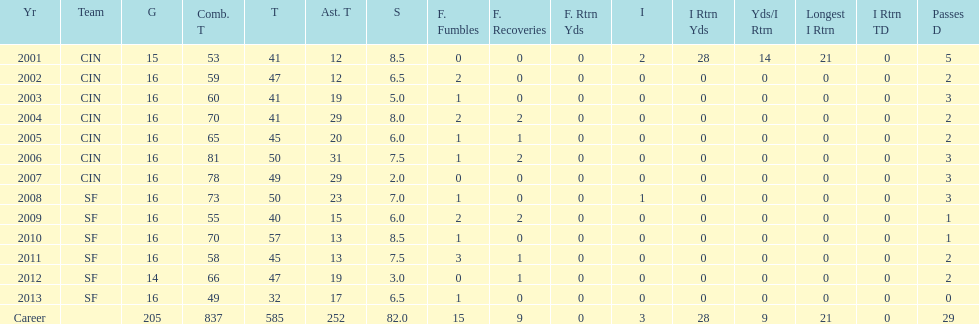How many seasons had combined tackles of 70 or more? 5. 